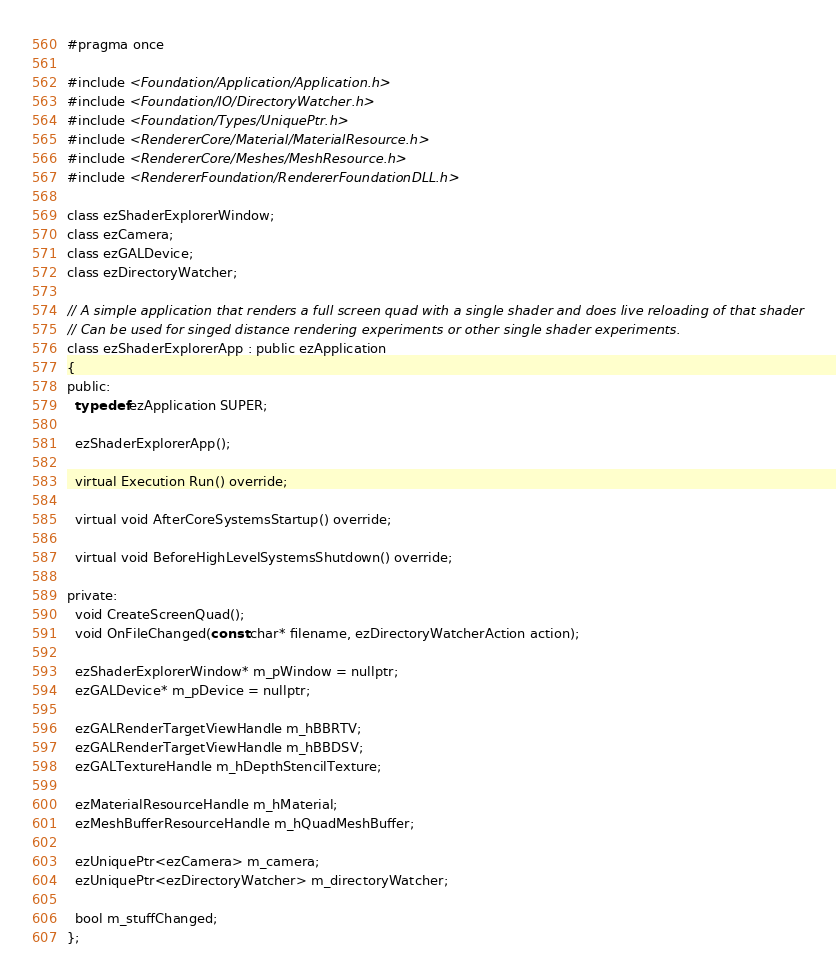Convert code to text. <code><loc_0><loc_0><loc_500><loc_500><_C_>#pragma once

#include <Foundation/Application/Application.h>
#include <Foundation/IO/DirectoryWatcher.h>
#include <Foundation/Types/UniquePtr.h>
#include <RendererCore/Material/MaterialResource.h>
#include <RendererCore/Meshes/MeshResource.h>
#include <RendererFoundation/RendererFoundationDLL.h>

class ezShaderExplorerWindow;
class ezCamera;
class ezGALDevice;
class ezDirectoryWatcher;

// A simple application that renders a full screen quad with a single shader and does live reloading of that shader
// Can be used for singed distance rendering experiments or other single shader experiments.
class ezShaderExplorerApp : public ezApplication
{
public:
  typedef ezApplication SUPER;

  ezShaderExplorerApp();

  virtual Execution Run() override;

  virtual void AfterCoreSystemsStartup() override;

  virtual void BeforeHighLevelSystemsShutdown() override;

private:
  void CreateScreenQuad();
  void OnFileChanged(const char* filename, ezDirectoryWatcherAction action);

  ezShaderExplorerWindow* m_pWindow = nullptr;
  ezGALDevice* m_pDevice = nullptr;

  ezGALRenderTargetViewHandle m_hBBRTV;
  ezGALRenderTargetViewHandle m_hBBDSV;
  ezGALTextureHandle m_hDepthStencilTexture;

  ezMaterialResourceHandle m_hMaterial;
  ezMeshBufferResourceHandle m_hQuadMeshBuffer;

  ezUniquePtr<ezCamera> m_camera;
  ezUniquePtr<ezDirectoryWatcher> m_directoryWatcher;

  bool m_stuffChanged;
};
</code> 